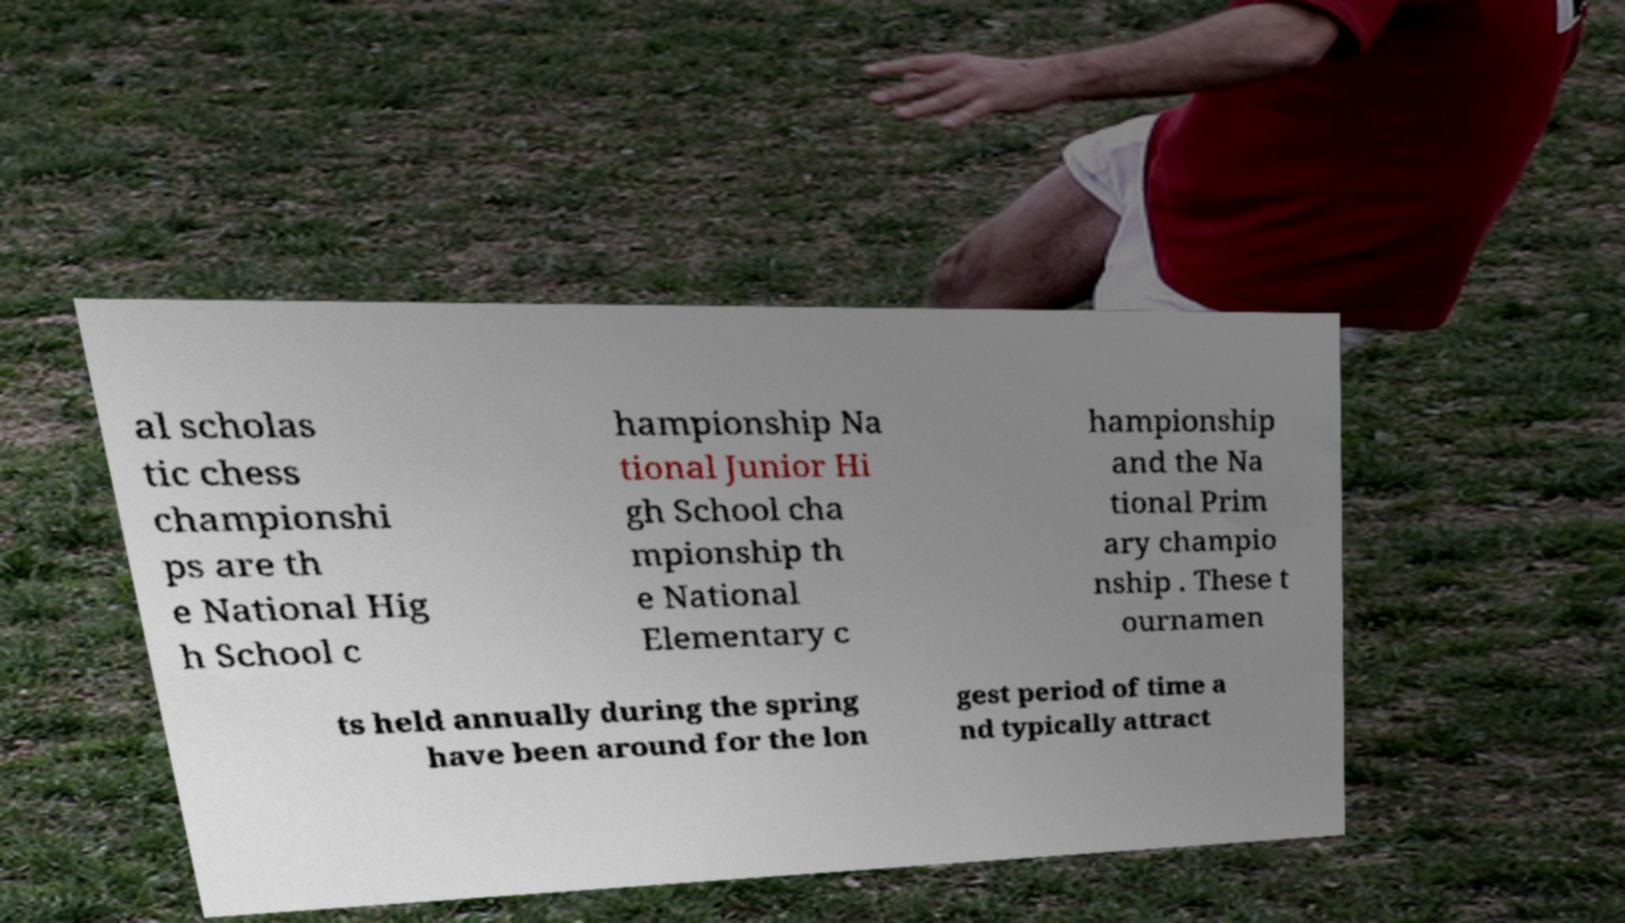Please read and relay the text visible in this image. What does it say? al scholas tic chess championshi ps are th e National Hig h School c hampionship Na tional Junior Hi gh School cha mpionship th e National Elementary c hampionship and the Na tional Prim ary champio nship . These t ournamen ts held annually during the spring have been around for the lon gest period of time a nd typically attract 